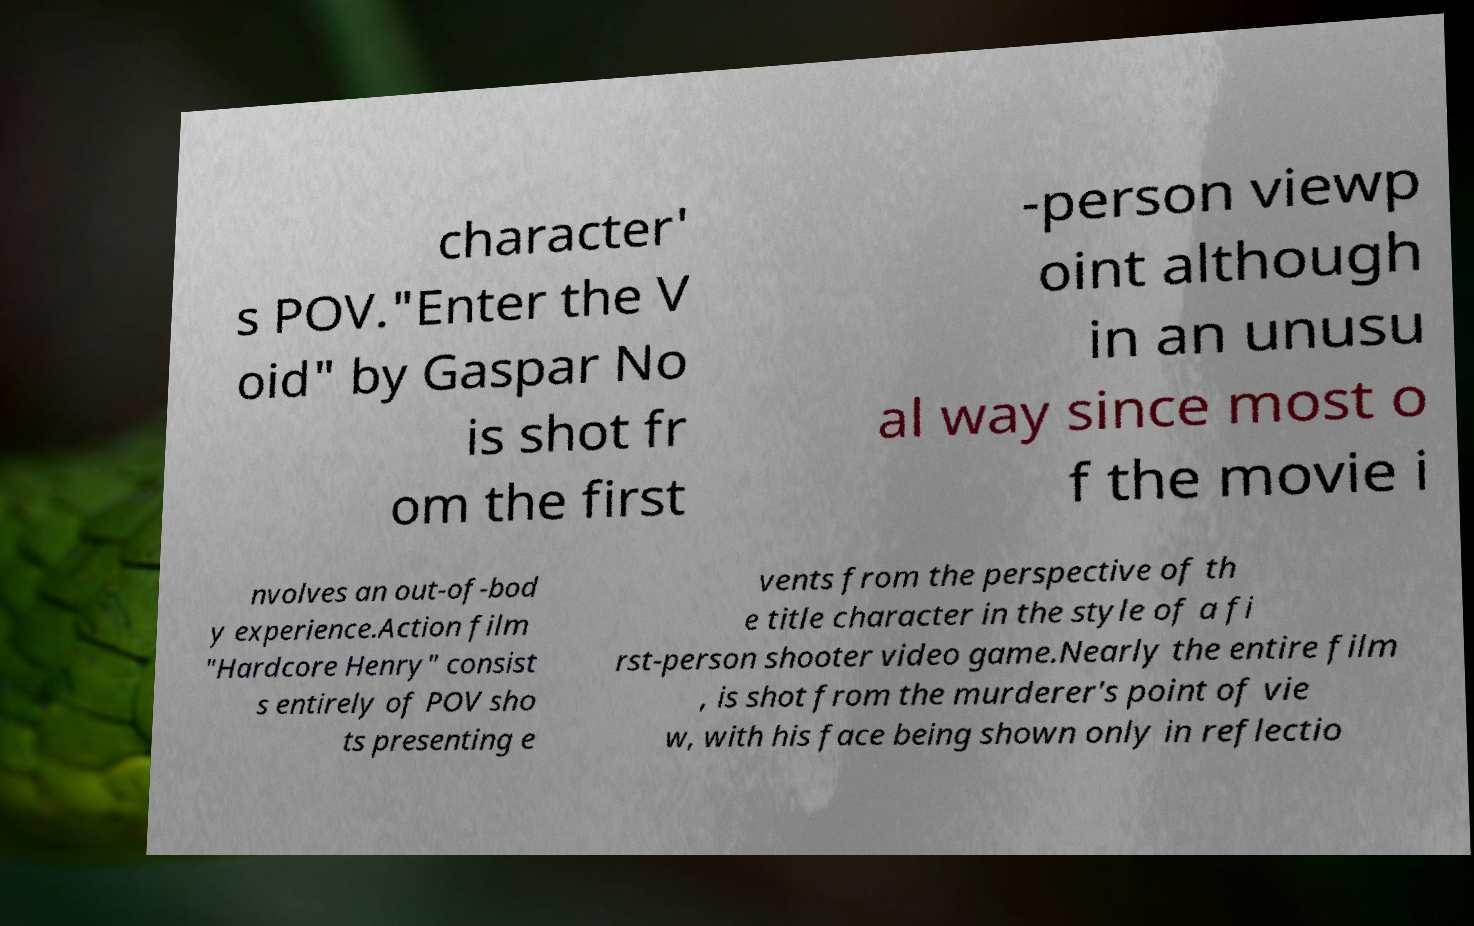There's text embedded in this image that I need extracted. Can you transcribe it verbatim? character' s POV."Enter the V oid" by Gaspar No is shot fr om the first -person viewp oint although in an unusu al way since most o f the movie i nvolves an out-of-bod y experience.Action film "Hardcore Henry" consist s entirely of POV sho ts presenting e vents from the perspective of th e title character in the style of a fi rst-person shooter video game.Nearly the entire film , is shot from the murderer's point of vie w, with his face being shown only in reflectio 